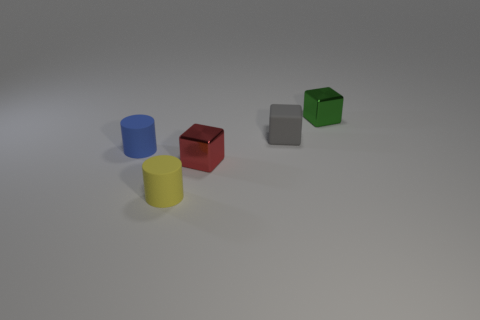Add 1 big brown matte objects. How many objects exist? 6 Subtract all blue cylinders. How many cylinders are left? 1 Subtract all small gray rubber blocks. How many blocks are left? 2 Subtract all cylinders. How many objects are left? 3 Subtract 1 cylinders. How many cylinders are left? 1 Add 4 tiny green metallic objects. How many tiny green metallic objects are left? 5 Add 2 small brown spheres. How many small brown spheres exist? 2 Subtract 0 cyan spheres. How many objects are left? 5 Subtract all yellow cylinders. Subtract all yellow balls. How many cylinders are left? 1 Subtract all cyan balls. How many gray cylinders are left? 0 